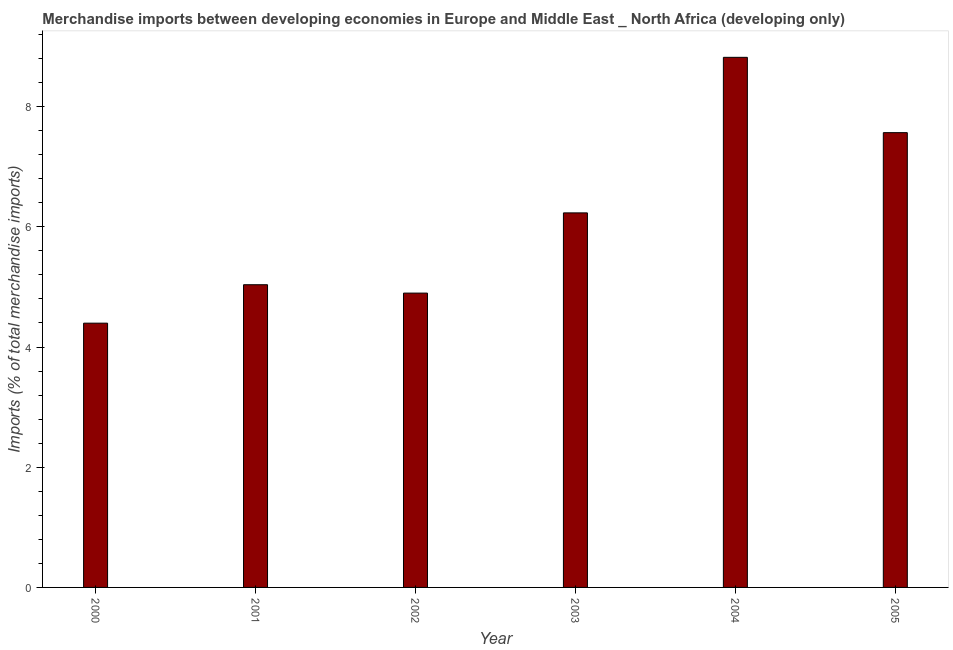What is the title of the graph?
Your answer should be very brief. Merchandise imports between developing economies in Europe and Middle East _ North Africa (developing only). What is the label or title of the X-axis?
Your answer should be very brief. Year. What is the label or title of the Y-axis?
Make the answer very short. Imports (% of total merchandise imports). What is the merchandise imports in 2000?
Provide a short and direct response. 4.4. Across all years, what is the maximum merchandise imports?
Provide a succinct answer. 8.82. Across all years, what is the minimum merchandise imports?
Your answer should be compact. 4.4. In which year was the merchandise imports maximum?
Provide a short and direct response. 2004. What is the sum of the merchandise imports?
Your answer should be very brief. 36.95. What is the difference between the merchandise imports in 2001 and 2004?
Ensure brevity in your answer.  -3.78. What is the average merchandise imports per year?
Your answer should be compact. 6.16. What is the median merchandise imports?
Keep it short and to the point. 5.63. Do a majority of the years between 2000 and 2004 (inclusive) have merchandise imports greater than 4.4 %?
Keep it short and to the point. Yes. What is the ratio of the merchandise imports in 2001 to that in 2002?
Make the answer very short. 1.03. Is the difference between the merchandise imports in 2001 and 2005 greater than the difference between any two years?
Your answer should be compact. No. What is the difference between the highest and the second highest merchandise imports?
Make the answer very short. 1.25. What is the difference between the highest and the lowest merchandise imports?
Keep it short and to the point. 4.42. Are the values on the major ticks of Y-axis written in scientific E-notation?
Offer a terse response. No. What is the Imports (% of total merchandise imports) in 2000?
Provide a short and direct response. 4.4. What is the Imports (% of total merchandise imports) in 2001?
Provide a short and direct response. 5.04. What is the Imports (% of total merchandise imports) in 2002?
Offer a terse response. 4.9. What is the Imports (% of total merchandise imports) in 2003?
Keep it short and to the point. 6.23. What is the Imports (% of total merchandise imports) in 2004?
Keep it short and to the point. 8.82. What is the Imports (% of total merchandise imports) in 2005?
Offer a terse response. 7.57. What is the difference between the Imports (% of total merchandise imports) in 2000 and 2001?
Give a very brief answer. -0.64. What is the difference between the Imports (% of total merchandise imports) in 2000 and 2002?
Make the answer very short. -0.5. What is the difference between the Imports (% of total merchandise imports) in 2000 and 2003?
Your answer should be compact. -1.83. What is the difference between the Imports (% of total merchandise imports) in 2000 and 2004?
Your answer should be compact. -4.42. What is the difference between the Imports (% of total merchandise imports) in 2000 and 2005?
Provide a short and direct response. -3.17. What is the difference between the Imports (% of total merchandise imports) in 2001 and 2002?
Provide a short and direct response. 0.14. What is the difference between the Imports (% of total merchandise imports) in 2001 and 2003?
Make the answer very short. -1.2. What is the difference between the Imports (% of total merchandise imports) in 2001 and 2004?
Make the answer very short. -3.78. What is the difference between the Imports (% of total merchandise imports) in 2001 and 2005?
Ensure brevity in your answer.  -2.53. What is the difference between the Imports (% of total merchandise imports) in 2002 and 2003?
Offer a very short reply. -1.33. What is the difference between the Imports (% of total merchandise imports) in 2002 and 2004?
Offer a very short reply. -3.92. What is the difference between the Imports (% of total merchandise imports) in 2002 and 2005?
Offer a terse response. -2.67. What is the difference between the Imports (% of total merchandise imports) in 2003 and 2004?
Your answer should be very brief. -2.59. What is the difference between the Imports (% of total merchandise imports) in 2003 and 2005?
Offer a very short reply. -1.33. What is the difference between the Imports (% of total merchandise imports) in 2004 and 2005?
Give a very brief answer. 1.25. What is the ratio of the Imports (% of total merchandise imports) in 2000 to that in 2001?
Make the answer very short. 0.87. What is the ratio of the Imports (% of total merchandise imports) in 2000 to that in 2002?
Provide a succinct answer. 0.9. What is the ratio of the Imports (% of total merchandise imports) in 2000 to that in 2003?
Ensure brevity in your answer.  0.71. What is the ratio of the Imports (% of total merchandise imports) in 2000 to that in 2004?
Offer a terse response. 0.5. What is the ratio of the Imports (% of total merchandise imports) in 2000 to that in 2005?
Make the answer very short. 0.58. What is the ratio of the Imports (% of total merchandise imports) in 2001 to that in 2002?
Give a very brief answer. 1.03. What is the ratio of the Imports (% of total merchandise imports) in 2001 to that in 2003?
Offer a terse response. 0.81. What is the ratio of the Imports (% of total merchandise imports) in 2001 to that in 2004?
Give a very brief answer. 0.57. What is the ratio of the Imports (% of total merchandise imports) in 2001 to that in 2005?
Offer a very short reply. 0.67. What is the ratio of the Imports (% of total merchandise imports) in 2002 to that in 2003?
Provide a succinct answer. 0.79. What is the ratio of the Imports (% of total merchandise imports) in 2002 to that in 2004?
Make the answer very short. 0.56. What is the ratio of the Imports (% of total merchandise imports) in 2002 to that in 2005?
Offer a terse response. 0.65. What is the ratio of the Imports (% of total merchandise imports) in 2003 to that in 2004?
Your response must be concise. 0.71. What is the ratio of the Imports (% of total merchandise imports) in 2003 to that in 2005?
Your answer should be compact. 0.82. What is the ratio of the Imports (% of total merchandise imports) in 2004 to that in 2005?
Keep it short and to the point. 1.17. 